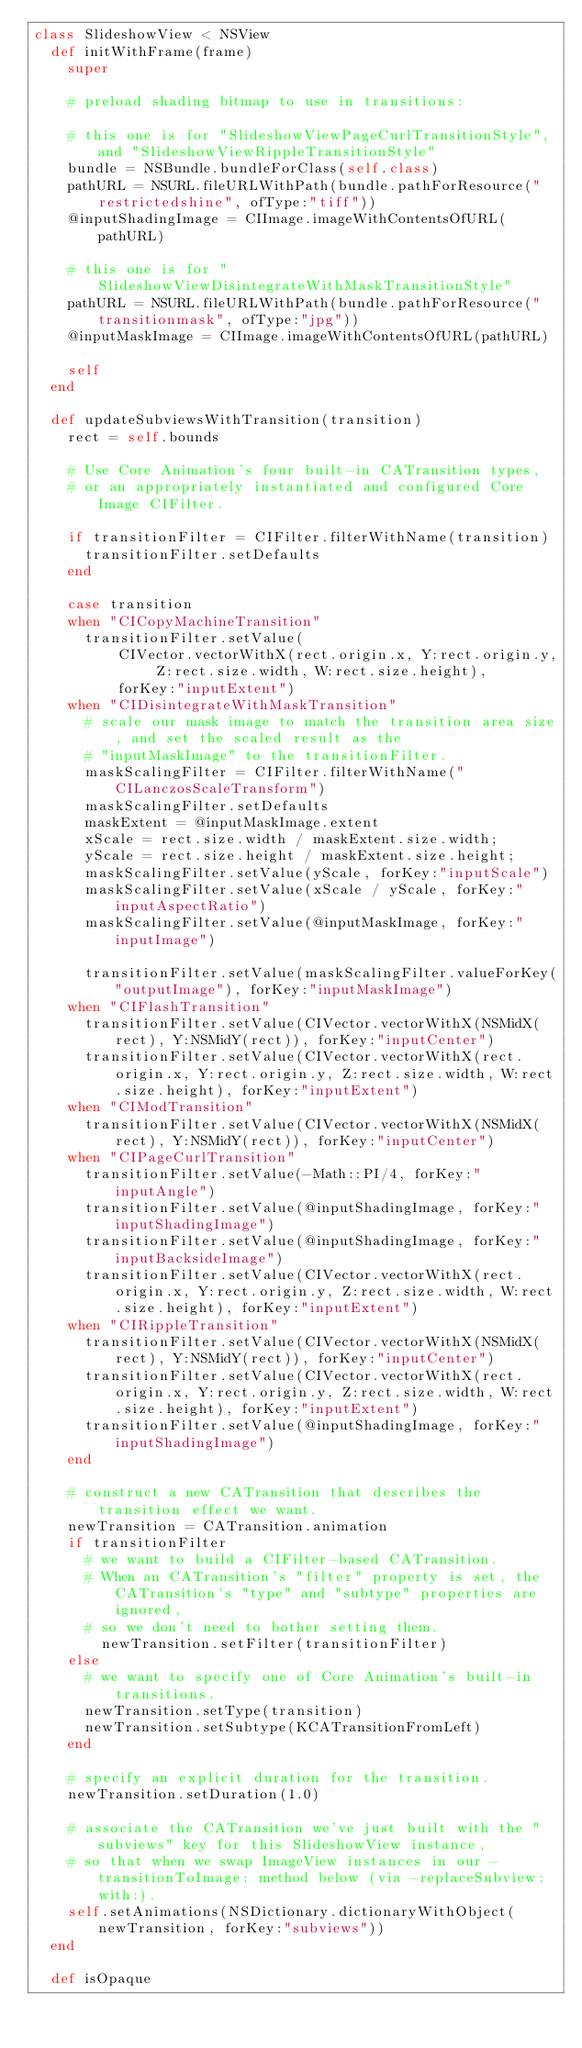Convert code to text. <code><loc_0><loc_0><loc_500><loc_500><_Ruby_>class SlideshowView < NSView
  def initWithFrame(frame)
    super

    # preload shading bitmap to use in transitions:

    # this one is for "SlideshowViewPageCurlTransitionStyle", and "SlideshowViewRippleTransitionStyle"
    bundle = NSBundle.bundleForClass(self.class)
    pathURL = NSURL.fileURLWithPath(bundle.pathForResource("restrictedshine", ofType:"tiff"))
    @inputShadingImage = CIImage.imageWithContentsOfURL(pathURL)

    # this one is for "SlideshowViewDisintegrateWithMaskTransitionStyle"
    pathURL = NSURL.fileURLWithPath(bundle.pathForResource("transitionmask", ofType:"jpg"))
    @inputMaskImage = CIImage.imageWithContentsOfURL(pathURL)

    self
  end

  def updateSubviewsWithTransition(transition)
    rect = self.bounds

    # Use Core Animation's four built-in CATransition types,
    # or an appropriately instantiated and configured Core Image CIFilter.

    if transitionFilter = CIFilter.filterWithName(transition)
      transitionFilter.setDefaults
    end

    case transition
    when "CICopyMachineTransition"
      transitionFilter.setValue(
          CIVector.vectorWithX(rect.origin.x, Y:rect.origin.y, Z:rect.size.width, W:rect.size.height),
          forKey:"inputExtent")
    when "CIDisintegrateWithMaskTransition"
      # scale our mask image to match the transition area size, and set the scaled result as the
      # "inputMaskImage" to the transitionFilter.
      maskScalingFilter = CIFilter.filterWithName("CILanczosScaleTransform")
      maskScalingFilter.setDefaults
      maskExtent = @inputMaskImage.extent
      xScale = rect.size.width / maskExtent.size.width;
      yScale = rect.size.height / maskExtent.size.height;
      maskScalingFilter.setValue(yScale, forKey:"inputScale")
      maskScalingFilter.setValue(xScale / yScale, forKey:"inputAspectRatio")
      maskScalingFilter.setValue(@inputMaskImage, forKey:"inputImage")

      transitionFilter.setValue(maskScalingFilter.valueForKey("outputImage"), forKey:"inputMaskImage")
    when "CIFlashTransition"
      transitionFilter.setValue(CIVector.vectorWithX(NSMidX(rect), Y:NSMidY(rect)), forKey:"inputCenter")
      transitionFilter.setValue(CIVector.vectorWithX(rect.origin.x, Y:rect.origin.y, Z:rect.size.width, W:rect.size.height), forKey:"inputExtent")
    when "CIModTransition"
      transitionFilter.setValue(CIVector.vectorWithX(NSMidX(rect), Y:NSMidY(rect)), forKey:"inputCenter")
    when "CIPageCurlTransition"
      transitionFilter.setValue(-Math::PI/4, forKey:"inputAngle")
      transitionFilter.setValue(@inputShadingImage, forKey:"inputShadingImage")
      transitionFilter.setValue(@inputShadingImage, forKey:"inputBacksideImage")
      transitionFilter.setValue(CIVector.vectorWithX(rect.origin.x, Y:rect.origin.y, Z:rect.size.width, W:rect.size.height), forKey:"inputExtent")
    when "CIRippleTransition"
      transitionFilter.setValue(CIVector.vectorWithX(NSMidX(rect), Y:NSMidY(rect)), forKey:"inputCenter")
      transitionFilter.setValue(CIVector.vectorWithX(rect.origin.x, Y:rect.origin.y, Z:rect.size.width, W:rect.size.height), forKey:"inputExtent")
      transitionFilter.setValue(@inputShadingImage, forKey:"inputShadingImage")
    end

    # construct a new CATransition that describes the transition effect we want.
    newTransition = CATransition.animation
    if transitionFilter
      # we want to build a CIFilter-based CATransition.
      # When an CATransition's "filter" property is set, the CATransition's "type" and "subtype" properties are ignored,
      # so we don't need to bother setting them.
        newTransition.setFilter(transitionFilter)
    else
      # we want to specify one of Core Animation's built-in transitions.
      newTransition.setType(transition)
      newTransition.setSubtype(KCATransitionFromLeft)
    end

    # specify an explicit duration for the transition.
    newTransition.setDuration(1.0)

    # associate the CATransition we've just built with the "subviews" key for this SlideshowView instance,
    # so that when we swap ImageView instances in our -transitionToImage: method below (via -replaceSubview:with:).
    self.setAnimations(NSDictionary.dictionaryWithObject(newTransition, forKey:"subviews"))
  end

  def isOpaque</code> 